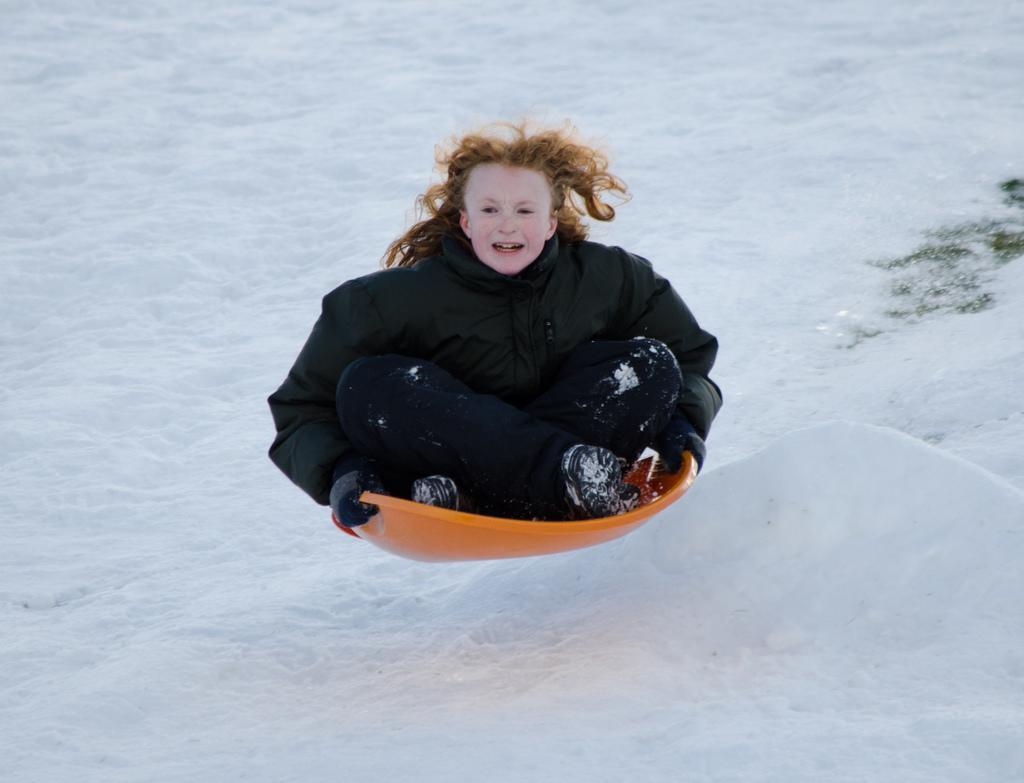Can you describe this image briefly? In this image there is a girl tubing on snow. 